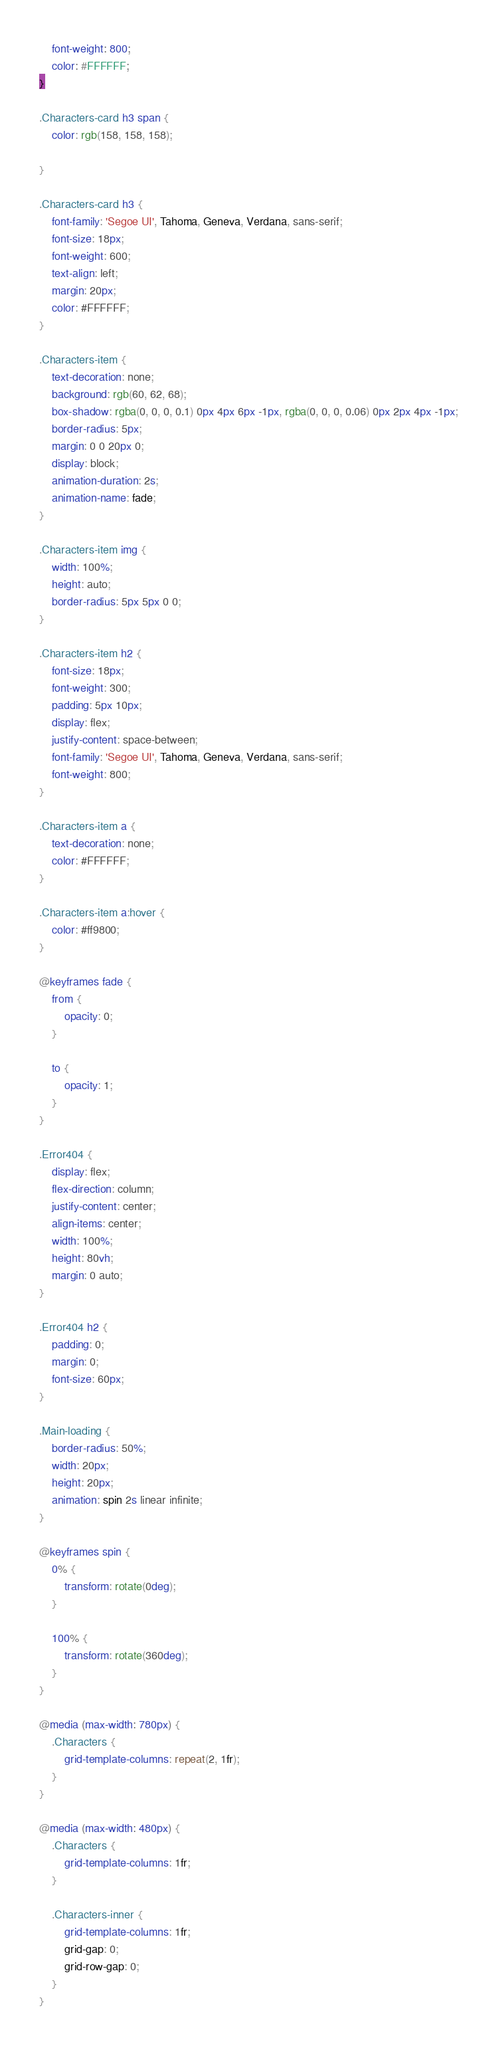Convert code to text. <code><loc_0><loc_0><loc_500><loc_500><_CSS_>    font-weight: 800;
    color: #FFFFFF;
}

.Characters-card h3 span {
    color: rgb(158, 158, 158);

}

.Characters-card h3 {
    font-family: 'Segoe UI', Tahoma, Geneva, Verdana, sans-serif;
    font-size: 18px;
    font-weight: 600;
    text-align: left;
    margin: 20px;
    color: #FFFFFF;
}

.Characters-item {
    text-decoration: none;
    background: rgb(60, 62, 68);
    box-shadow: rgba(0, 0, 0, 0.1) 0px 4px 6px -1px, rgba(0, 0, 0, 0.06) 0px 2px 4px -1px;
    border-radius: 5px;
    margin: 0 0 20px 0;
    display: block;
    animation-duration: 2s;
    animation-name: fade;
}

.Characters-item img {
    width: 100%;
    height: auto;
    border-radius: 5px 5px 0 0;
}

.Characters-item h2 {
    font-size: 18px;
    font-weight: 300;
    padding: 5px 10px;
    display: flex;
    justify-content: space-between;
    font-family: 'Segoe UI', Tahoma, Geneva, Verdana, sans-serif;
    font-weight: 800;
}

.Characters-item a {
    text-decoration: none;
    color: #FFFFFF;
}

.Characters-item a:hover {
    color: #ff9800;
}

@keyframes fade {
    from {
        opacity: 0;
    }

    to {
        opacity: 1;
    }
}

.Error404 {
    display: flex;
    flex-direction: column;
    justify-content: center;
    align-items: center;
    width: 100%;
    height: 80vh;
    margin: 0 auto;
}

.Error404 h2 {
    padding: 0;
    margin: 0;
    font-size: 60px;
}

.Main-loading {
    border-radius: 50%;
    width: 20px;
    height: 20px;
    animation: spin 2s linear infinite;
}

@keyframes spin {
    0% {
        transform: rotate(0deg);
    }

    100% {
        transform: rotate(360deg);
    }
}

@media (max-width: 780px) {
	.Characters {
		grid-template-columns: repeat(2, 1fr);
	}
}

@media (max-width: 480px) {
	.Characters {
		grid-template-columns: 1fr;
	}

	.Characters-inner {
		grid-template-columns: 1fr;
		grid-gap: 0;
		grid-row-gap: 0;
	}
}</code> 